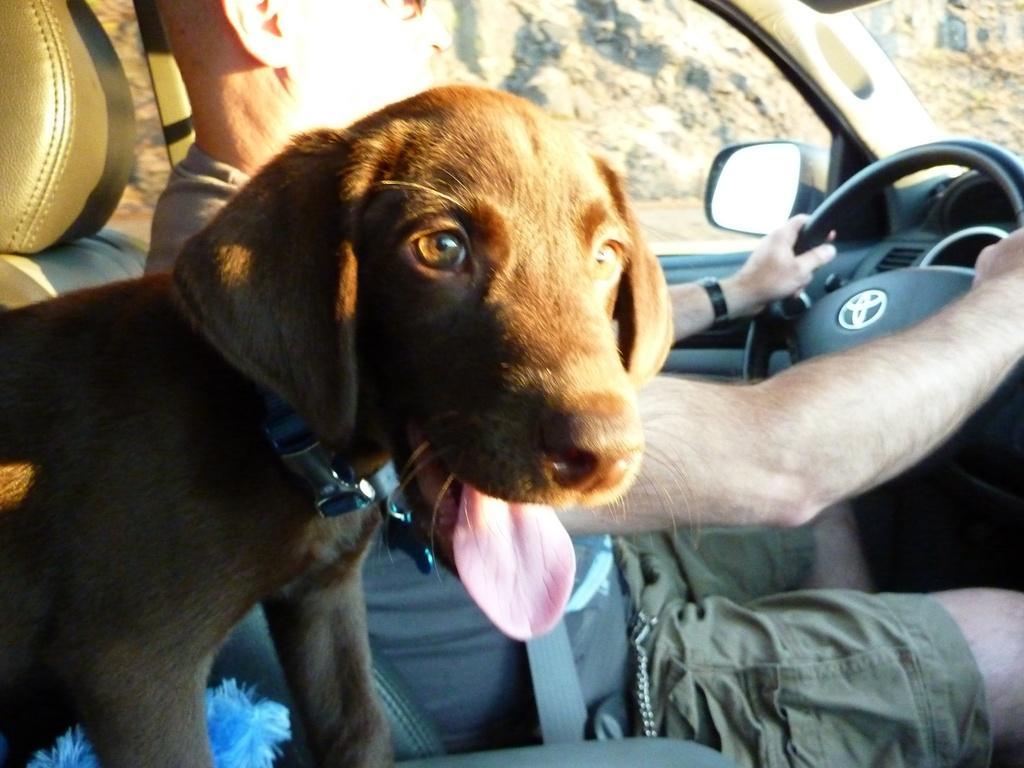In one or two sentences, can you explain what this image depicts? In the middle of the image there is a man sitting on a vehicle. Bottom left side of the image there is a dog on the vehicle. Through the window we can see the hill. 